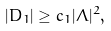Convert formula to latex. <formula><loc_0><loc_0><loc_500><loc_500>| D _ { 1 } | \geq c _ { 1 } | \Lambda | ^ { 2 } ,</formula> 